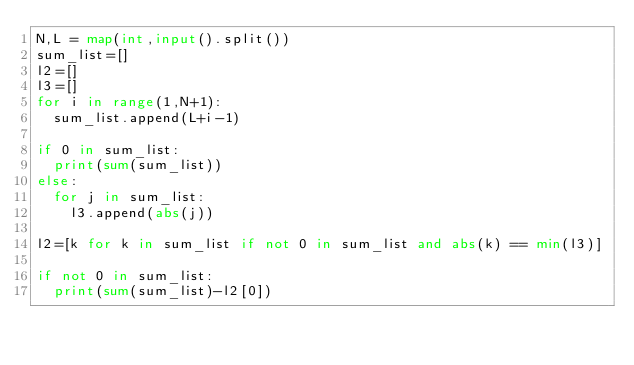Convert code to text. <code><loc_0><loc_0><loc_500><loc_500><_Python_>N,L = map(int,input().split())
sum_list=[]
l2=[]
l3=[]
for i in range(1,N+1):
  sum_list.append(L+i-1)
  
if 0 in sum_list:
  print(sum(sum_list))
else:
  for j in sum_list:
    l3.append(abs(j))

l2=[k for k in sum_list if not 0 in sum_list and abs(k) == min(l3)]

if not 0 in sum_list:
  print(sum(sum_list)-l2[0])</code> 